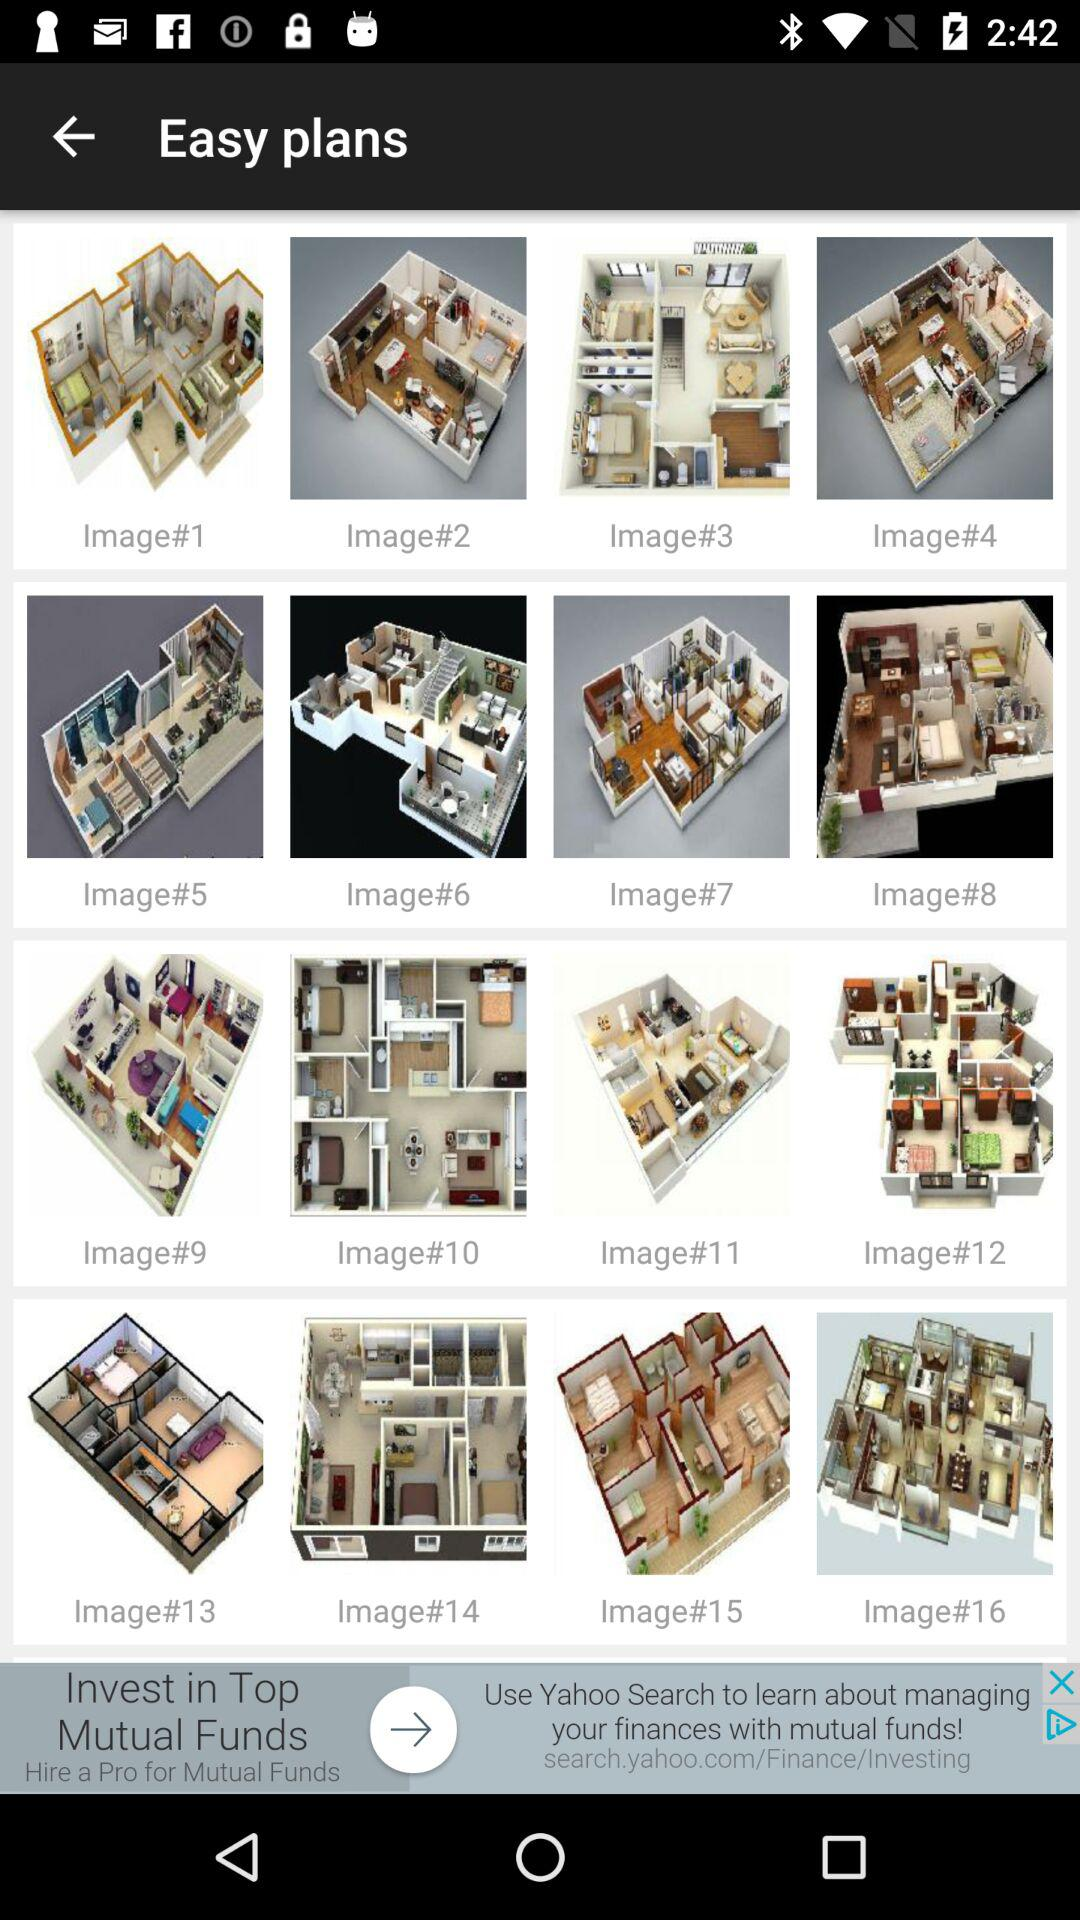How many images are there? There are 16 images. 